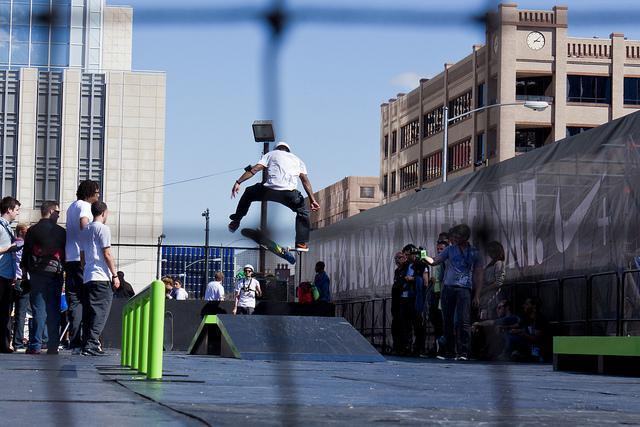How many people are there?
Give a very brief answer. 9. 